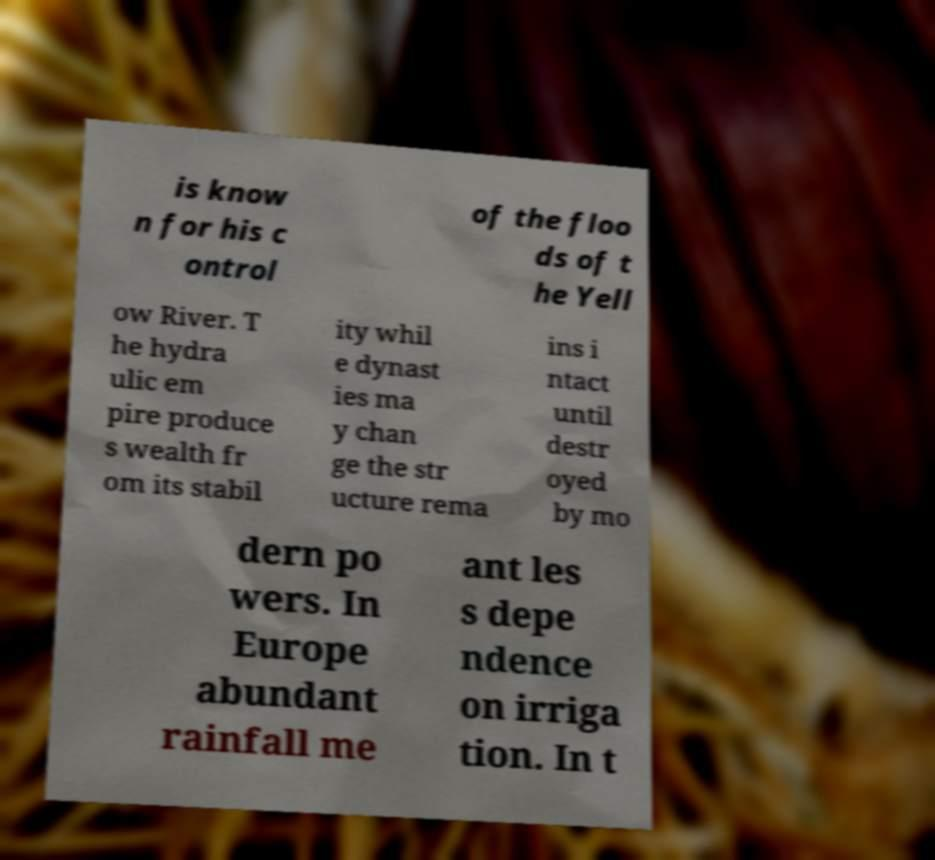For documentation purposes, I need the text within this image transcribed. Could you provide that? is know n for his c ontrol of the floo ds of t he Yell ow River. T he hydra ulic em pire produce s wealth fr om its stabil ity whil e dynast ies ma y chan ge the str ucture rema ins i ntact until destr oyed by mo dern po wers. In Europe abundant rainfall me ant les s depe ndence on irriga tion. In t 